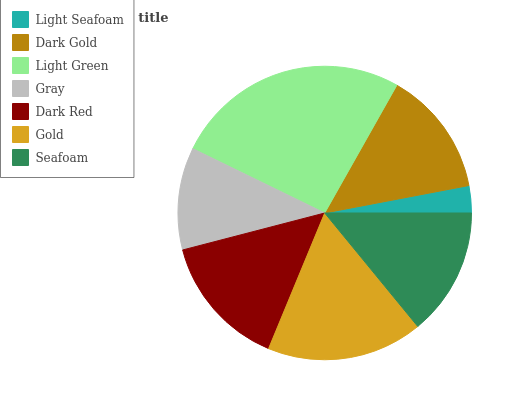Is Light Seafoam the minimum?
Answer yes or no. Yes. Is Light Green the maximum?
Answer yes or no. Yes. Is Dark Gold the minimum?
Answer yes or no. No. Is Dark Gold the maximum?
Answer yes or no. No. Is Dark Gold greater than Light Seafoam?
Answer yes or no. Yes. Is Light Seafoam less than Dark Gold?
Answer yes or no. Yes. Is Light Seafoam greater than Dark Gold?
Answer yes or no. No. Is Dark Gold less than Light Seafoam?
Answer yes or no. No. Is Seafoam the high median?
Answer yes or no. Yes. Is Seafoam the low median?
Answer yes or no. Yes. Is Gold the high median?
Answer yes or no. No. Is Dark Gold the low median?
Answer yes or no. No. 